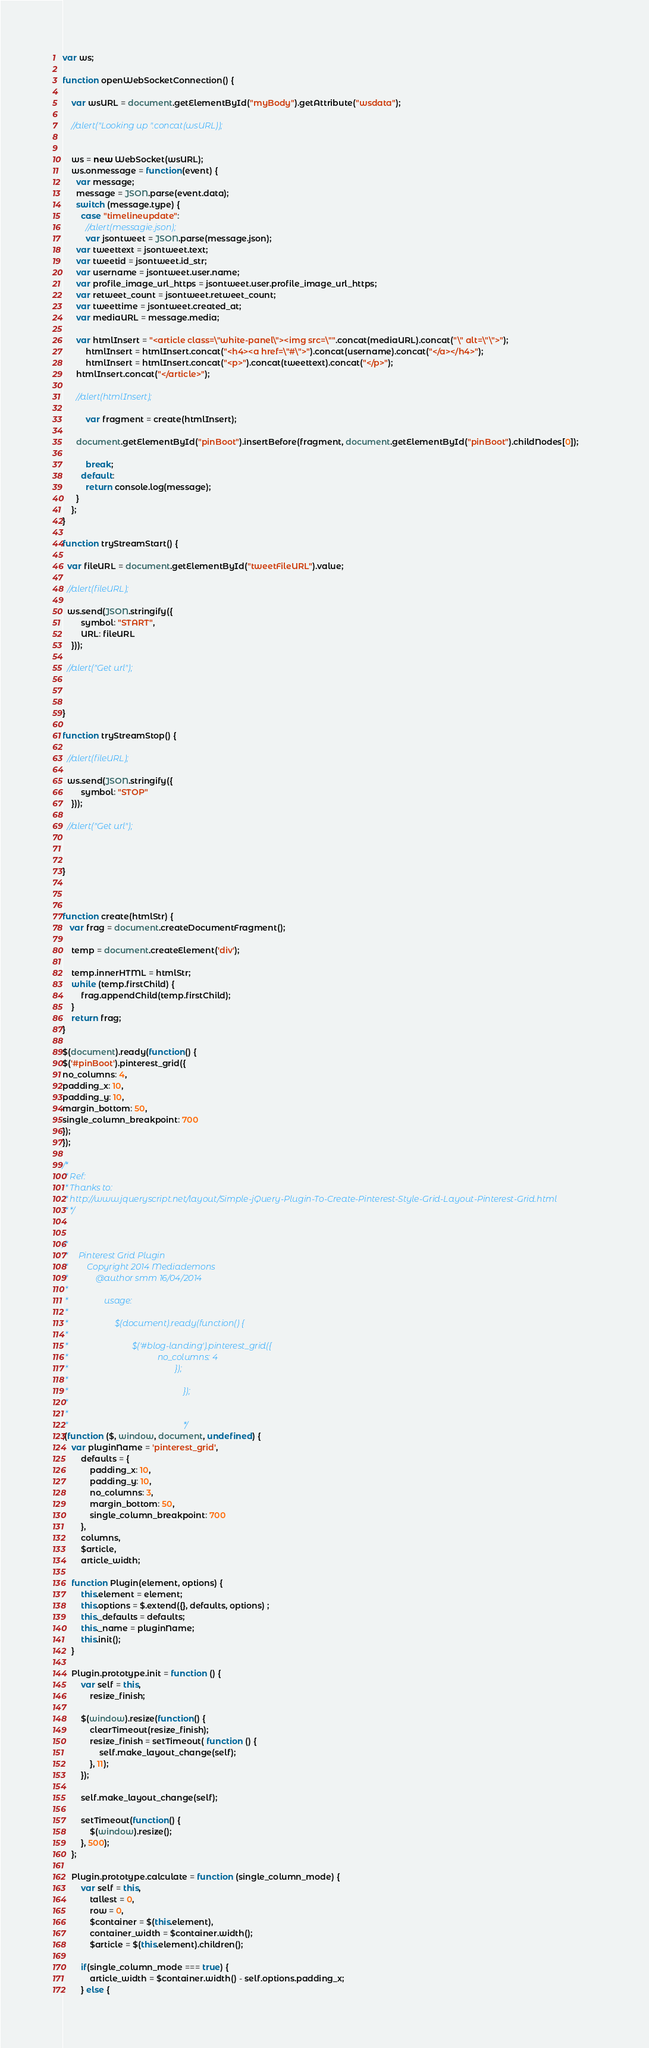<code> <loc_0><loc_0><loc_500><loc_500><_JavaScript_>var ws;

function openWebSocketConnection() {
    
    var wsURL = document.getElementById("myBody").getAttribute("wsdata"); 
    
	//alert("Looking up ".concat(wsURL));

    
    ws = new WebSocket(wsURL);
    ws.onmessage = function(event) {
      var message;
      message = JSON.parse(event.data);
      switch (message.type) {
        case "timelineupdate":
          //alert(messagie.json);
          var jsontweet = JSON.parse(message.json);
	  var tweettext = jsontweet.text;
	  var tweetid = jsontweet.id_str;
	  var username = jsontweet.user.name;
	  var profile_image_url_https = jsontweet.user.profile_image_url_https;
	  var retweet_count = jsontweet.retweet_count;
	  var tweettime = jsontweet.created_at;
	  var mediaURL = message.media;

	  var htmlInsert = "<article class=\"white-panel\"><img src=\"".concat(mediaURL).concat("\" alt=\"\">");
          htmlInsert = htmlInsert.concat("<h4><a href=\"#\">").concat(username).concat("</a></h4>");
          htmlInsert = htmlInsert.concat("<p>").concat(tweettext).concat("</p>");
	  htmlInsert.concat("</article>");
	
	  //alert(htmlInsert);

          var fragment = create(htmlInsert);
	  
	  document.getElementById("pinBoot").insertBefore(fragment, document.getElementById("pinBoot").childNodes[0]);		

          break;
        default:
          return console.log(message);
      }
    };
}

function tryStreamStart() {

  var fileURL = document.getElementById("tweetFileURL").value;
  
  //alert(fileURL);

  ws.send(JSON.stringify({
        symbol: "START",
        URL: fileURL
    }));

  //alert("Get url");

	

}

function tryStreamStop() {
  
  //alert(fileURL);

  ws.send(JSON.stringify({
        symbol: "STOP"
    }));

  //alert("Get url");

	

}



function create(htmlStr) {
   var frag = document.createDocumentFragment();

    temp = document.createElement('div');
        
    temp.innerHTML = htmlStr;
    while (temp.firstChild) {
        frag.appendChild(temp.firstChild);
    }
    return frag;
}

$(document).ready(function() {
$('#pinBoot').pinterest_grid({
no_columns: 4,
padding_x: 10,
padding_y: 10,
margin_bottom: 50,
single_column_breakpoint: 700
});
});

/*
 * Ref:
 * Thanks to:
 * http://www.jqueryscript.net/layout/Simple-jQuery-Plugin-To-Create-Pinterest-Style-Grid-Layout-Pinterest-Grid.html
 * */


/*
 *     Pinterest Grid Plugin
 *         Copyright 2014 Mediademons
 *             @author smm 16/04/2014
 *
 *                 usage:
 *
 *                      $(document).ready(function() {
 *
 *                              $('#blog-landing').pinterest_grid({
 *                                          no_columns: 4
 *                                                  });
 *
 *                                                      });
 *
 *
 *                                                      */
;(function ($, window, document, undefined) {
    var pluginName = 'pinterest_grid',
        defaults = {
            padding_x: 10,
            padding_y: 10,
            no_columns: 3,
            margin_bottom: 50,
            single_column_breakpoint: 700
        },
        columns,
        $article,
        article_width;

    function Plugin(element, options) {
        this.element = element;
        this.options = $.extend({}, defaults, options) ;
        this._defaults = defaults;
        this._name = pluginName;
        this.init();
    }

    Plugin.prototype.init = function () {
        var self = this,
            resize_finish;

        $(window).resize(function() {
            clearTimeout(resize_finish);
            resize_finish = setTimeout( function () {
                self.make_layout_change(self);
            }, 11);
        });

        self.make_layout_change(self);

        setTimeout(function() {
            $(window).resize();
        }, 500);
    };

    Plugin.prototype.calculate = function (single_column_mode) {
        var self = this,
            tallest = 0,
            row = 0,
            $container = $(this.element),
            container_width = $container.width();
            $article = $(this.element).children();

        if(single_column_mode === true) {
            article_width = $container.width() - self.options.padding_x;
        } else {</code> 